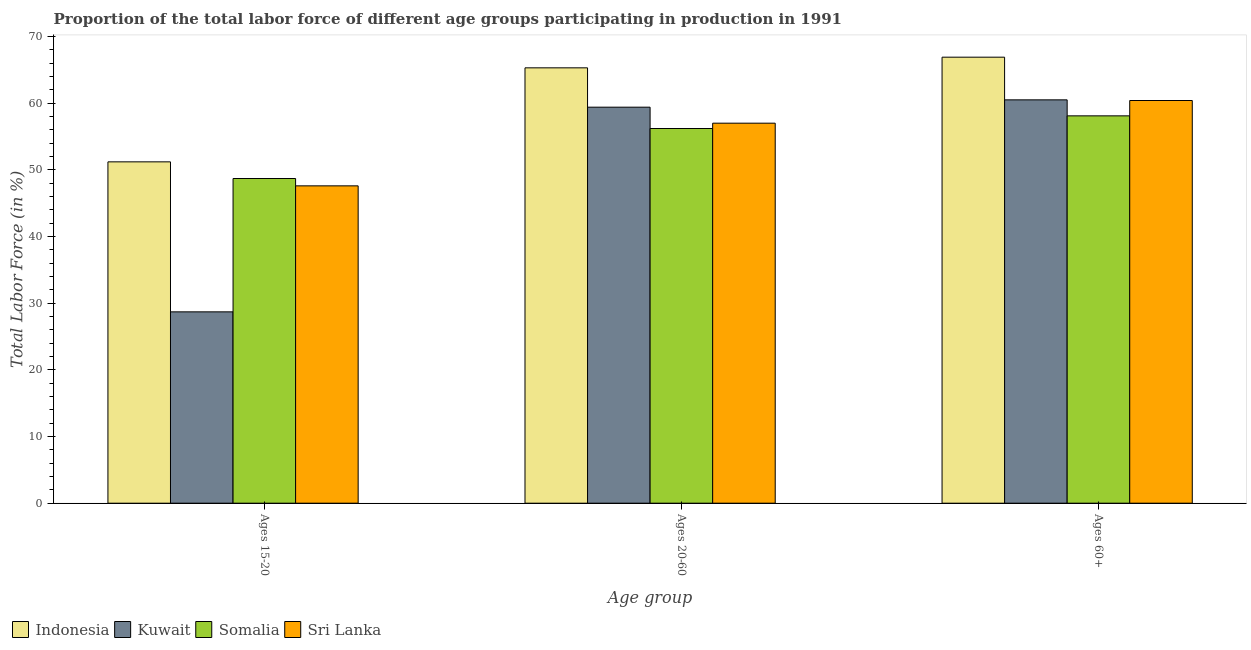How many different coloured bars are there?
Your answer should be very brief. 4. How many groups of bars are there?
Keep it short and to the point. 3. Are the number of bars per tick equal to the number of legend labels?
Offer a terse response. Yes. Are the number of bars on each tick of the X-axis equal?
Give a very brief answer. Yes. How many bars are there on the 2nd tick from the left?
Keep it short and to the point. 4. What is the label of the 2nd group of bars from the left?
Provide a short and direct response. Ages 20-60. What is the percentage of labor force within the age group 20-60 in Indonesia?
Provide a succinct answer. 65.3. Across all countries, what is the maximum percentage of labor force within the age group 15-20?
Provide a short and direct response. 51.2. Across all countries, what is the minimum percentage of labor force within the age group 20-60?
Your answer should be very brief. 56.2. In which country was the percentage of labor force above age 60 maximum?
Your answer should be very brief. Indonesia. In which country was the percentage of labor force within the age group 15-20 minimum?
Your response must be concise. Kuwait. What is the total percentage of labor force above age 60 in the graph?
Keep it short and to the point. 245.9. What is the difference between the percentage of labor force above age 60 in Somalia and that in Kuwait?
Provide a succinct answer. -2.4. What is the difference between the percentage of labor force above age 60 in Kuwait and the percentage of labor force within the age group 20-60 in Indonesia?
Provide a succinct answer. -4.8. What is the average percentage of labor force within the age group 15-20 per country?
Keep it short and to the point. 44.05. What is the difference between the percentage of labor force above age 60 and percentage of labor force within the age group 15-20 in Sri Lanka?
Your answer should be compact. 12.8. What is the ratio of the percentage of labor force within the age group 15-20 in Indonesia to that in Kuwait?
Provide a short and direct response. 1.78. Is the difference between the percentage of labor force above age 60 in Somalia and Kuwait greater than the difference between the percentage of labor force within the age group 20-60 in Somalia and Kuwait?
Provide a succinct answer. Yes. What is the difference between the highest and the second highest percentage of labor force above age 60?
Keep it short and to the point. 6.4. What is the difference between the highest and the lowest percentage of labor force within the age group 20-60?
Make the answer very short. 9.1. In how many countries, is the percentage of labor force above age 60 greater than the average percentage of labor force above age 60 taken over all countries?
Make the answer very short. 1. Is the sum of the percentage of labor force above age 60 in Indonesia and Somalia greater than the maximum percentage of labor force within the age group 15-20 across all countries?
Offer a very short reply. Yes. What does the 1st bar from the left in Ages 15-20 represents?
Provide a succinct answer. Indonesia. What does the 3rd bar from the right in Ages 60+ represents?
Your answer should be compact. Kuwait. How many bars are there?
Keep it short and to the point. 12. Are all the bars in the graph horizontal?
Provide a short and direct response. No. How many countries are there in the graph?
Provide a short and direct response. 4. What is the difference between two consecutive major ticks on the Y-axis?
Ensure brevity in your answer.  10. Does the graph contain any zero values?
Make the answer very short. No. Does the graph contain grids?
Your answer should be very brief. No. Where does the legend appear in the graph?
Provide a succinct answer. Bottom left. How many legend labels are there?
Give a very brief answer. 4. How are the legend labels stacked?
Provide a short and direct response. Horizontal. What is the title of the graph?
Provide a succinct answer. Proportion of the total labor force of different age groups participating in production in 1991. Does "Thailand" appear as one of the legend labels in the graph?
Provide a short and direct response. No. What is the label or title of the X-axis?
Your response must be concise. Age group. What is the label or title of the Y-axis?
Keep it short and to the point. Total Labor Force (in %). What is the Total Labor Force (in %) of Indonesia in Ages 15-20?
Your response must be concise. 51.2. What is the Total Labor Force (in %) in Kuwait in Ages 15-20?
Provide a short and direct response. 28.7. What is the Total Labor Force (in %) of Somalia in Ages 15-20?
Provide a succinct answer. 48.7. What is the Total Labor Force (in %) in Sri Lanka in Ages 15-20?
Offer a terse response. 47.6. What is the Total Labor Force (in %) in Indonesia in Ages 20-60?
Ensure brevity in your answer.  65.3. What is the Total Labor Force (in %) of Kuwait in Ages 20-60?
Provide a succinct answer. 59.4. What is the Total Labor Force (in %) of Somalia in Ages 20-60?
Offer a terse response. 56.2. What is the Total Labor Force (in %) of Indonesia in Ages 60+?
Offer a terse response. 66.9. What is the Total Labor Force (in %) of Kuwait in Ages 60+?
Provide a short and direct response. 60.5. What is the Total Labor Force (in %) in Somalia in Ages 60+?
Offer a very short reply. 58.1. What is the Total Labor Force (in %) of Sri Lanka in Ages 60+?
Give a very brief answer. 60.4. Across all Age group, what is the maximum Total Labor Force (in %) in Indonesia?
Ensure brevity in your answer.  66.9. Across all Age group, what is the maximum Total Labor Force (in %) of Kuwait?
Offer a terse response. 60.5. Across all Age group, what is the maximum Total Labor Force (in %) of Somalia?
Offer a terse response. 58.1. Across all Age group, what is the maximum Total Labor Force (in %) in Sri Lanka?
Ensure brevity in your answer.  60.4. Across all Age group, what is the minimum Total Labor Force (in %) of Indonesia?
Give a very brief answer. 51.2. Across all Age group, what is the minimum Total Labor Force (in %) of Kuwait?
Provide a succinct answer. 28.7. Across all Age group, what is the minimum Total Labor Force (in %) of Somalia?
Offer a terse response. 48.7. Across all Age group, what is the minimum Total Labor Force (in %) in Sri Lanka?
Provide a succinct answer. 47.6. What is the total Total Labor Force (in %) of Indonesia in the graph?
Ensure brevity in your answer.  183.4. What is the total Total Labor Force (in %) in Kuwait in the graph?
Keep it short and to the point. 148.6. What is the total Total Labor Force (in %) of Somalia in the graph?
Keep it short and to the point. 163. What is the total Total Labor Force (in %) in Sri Lanka in the graph?
Offer a terse response. 165. What is the difference between the Total Labor Force (in %) in Indonesia in Ages 15-20 and that in Ages 20-60?
Offer a very short reply. -14.1. What is the difference between the Total Labor Force (in %) of Kuwait in Ages 15-20 and that in Ages 20-60?
Your answer should be very brief. -30.7. What is the difference between the Total Labor Force (in %) in Sri Lanka in Ages 15-20 and that in Ages 20-60?
Provide a succinct answer. -9.4. What is the difference between the Total Labor Force (in %) in Indonesia in Ages 15-20 and that in Ages 60+?
Give a very brief answer. -15.7. What is the difference between the Total Labor Force (in %) of Kuwait in Ages 15-20 and that in Ages 60+?
Ensure brevity in your answer.  -31.8. What is the difference between the Total Labor Force (in %) of Sri Lanka in Ages 15-20 and that in Ages 60+?
Offer a very short reply. -12.8. What is the difference between the Total Labor Force (in %) of Indonesia in Ages 20-60 and that in Ages 60+?
Provide a short and direct response. -1.6. What is the difference between the Total Labor Force (in %) in Kuwait in Ages 20-60 and that in Ages 60+?
Ensure brevity in your answer.  -1.1. What is the difference between the Total Labor Force (in %) of Somalia in Ages 20-60 and that in Ages 60+?
Provide a succinct answer. -1.9. What is the difference between the Total Labor Force (in %) of Sri Lanka in Ages 20-60 and that in Ages 60+?
Provide a short and direct response. -3.4. What is the difference between the Total Labor Force (in %) of Indonesia in Ages 15-20 and the Total Labor Force (in %) of Sri Lanka in Ages 20-60?
Your response must be concise. -5.8. What is the difference between the Total Labor Force (in %) of Kuwait in Ages 15-20 and the Total Labor Force (in %) of Somalia in Ages 20-60?
Make the answer very short. -27.5. What is the difference between the Total Labor Force (in %) in Kuwait in Ages 15-20 and the Total Labor Force (in %) in Sri Lanka in Ages 20-60?
Ensure brevity in your answer.  -28.3. What is the difference between the Total Labor Force (in %) in Indonesia in Ages 15-20 and the Total Labor Force (in %) in Kuwait in Ages 60+?
Your response must be concise. -9.3. What is the difference between the Total Labor Force (in %) in Indonesia in Ages 15-20 and the Total Labor Force (in %) in Somalia in Ages 60+?
Give a very brief answer. -6.9. What is the difference between the Total Labor Force (in %) of Kuwait in Ages 15-20 and the Total Labor Force (in %) of Somalia in Ages 60+?
Your response must be concise. -29.4. What is the difference between the Total Labor Force (in %) in Kuwait in Ages 15-20 and the Total Labor Force (in %) in Sri Lanka in Ages 60+?
Make the answer very short. -31.7. What is the difference between the Total Labor Force (in %) of Somalia in Ages 15-20 and the Total Labor Force (in %) of Sri Lanka in Ages 60+?
Give a very brief answer. -11.7. What is the difference between the Total Labor Force (in %) of Indonesia in Ages 20-60 and the Total Labor Force (in %) of Kuwait in Ages 60+?
Give a very brief answer. 4.8. What is the difference between the Total Labor Force (in %) in Indonesia in Ages 20-60 and the Total Labor Force (in %) in Sri Lanka in Ages 60+?
Your answer should be compact. 4.9. What is the average Total Labor Force (in %) in Indonesia per Age group?
Ensure brevity in your answer.  61.13. What is the average Total Labor Force (in %) of Kuwait per Age group?
Give a very brief answer. 49.53. What is the average Total Labor Force (in %) in Somalia per Age group?
Your answer should be compact. 54.33. What is the difference between the Total Labor Force (in %) of Indonesia and Total Labor Force (in %) of Somalia in Ages 15-20?
Offer a very short reply. 2.5. What is the difference between the Total Labor Force (in %) in Indonesia and Total Labor Force (in %) in Sri Lanka in Ages 15-20?
Offer a terse response. 3.6. What is the difference between the Total Labor Force (in %) of Kuwait and Total Labor Force (in %) of Somalia in Ages 15-20?
Give a very brief answer. -20. What is the difference between the Total Labor Force (in %) in Kuwait and Total Labor Force (in %) in Sri Lanka in Ages 15-20?
Your answer should be compact. -18.9. What is the difference between the Total Labor Force (in %) in Indonesia and Total Labor Force (in %) in Somalia in Ages 20-60?
Keep it short and to the point. 9.1. What is the difference between the Total Labor Force (in %) of Indonesia and Total Labor Force (in %) of Sri Lanka in Ages 20-60?
Your response must be concise. 8.3. What is the difference between the Total Labor Force (in %) of Kuwait and Total Labor Force (in %) of Somalia in Ages 20-60?
Provide a short and direct response. 3.2. What is the difference between the Total Labor Force (in %) of Kuwait and Total Labor Force (in %) of Sri Lanka in Ages 20-60?
Make the answer very short. 2.4. What is the difference between the Total Labor Force (in %) of Indonesia and Total Labor Force (in %) of Somalia in Ages 60+?
Provide a succinct answer. 8.8. What is the difference between the Total Labor Force (in %) in Kuwait and Total Labor Force (in %) in Somalia in Ages 60+?
Ensure brevity in your answer.  2.4. What is the difference between the Total Labor Force (in %) of Somalia and Total Labor Force (in %) of Sri Lanka in Ages 60+?
Your answer should be very brief. -2.3. What is the ratio of the Total Labor Force (in %) of Indonesia in Ages 15-20 to that in Ages 20-60?
Ensure brevity in your answer.  0.78. What is the ratio of the Total Labor Force (in %) of Kuwait in Ages 15-20 to that in Ages 20-60?
Keep it short and to the point. 0.48. What is the ratio of the Total Labor Force (in %) in Somalia in Ages 15-20 to that in Ages 20-60?
Offer a terse response. 0.87. What is the ratio of the Total Labor Force (in %) of Sri Lanka in Ages 15-20 to that in Ages 20-60?
Your answer should be very brief. 0.84. What is the ratio of the Total Labor Force (in %) in Indonesia in Ages 15-20 to that in Ages 60+?
Your answer should be very brief. 0.77. What is the ratio of the Total Labor Force (in %) of Kuwait in Ages 15-20 to that in Ages 60+?
Your answer should be very brief. 0.47. What is the ratio of the Total Labor Force (in %) of Somalia in Ages 15-20 to that in Ages 60+?
Provide a short and direct response. 0.84. What is the ratio of the Total Labor Force (in %) of Sri Lanka in Ages 15-20 to that in Ages 60+?
Offer a very short reply. 0.79. What is the ratio of the Total Labor Force (in %) in Indonesia in Ages 20-60 to that in Ages 60+?
Provide a short and direct response. 0.98. What is the ratio of the Total Labor Force (in %) of Kuwait in Ages 20-60 to that in Ages 60+?
Provide a succinct answer. 0.98. What is the ratio of the Total Labor Force (in %) of Somalia in Ages 20-60 to that in Ages 60+?
Provide a short and direct response. 0.97. What is the ratio of the Total Labor Force (in %) in Sri Lanka in Ages 20-60 to that in Ages 60+?
Keep it short and to the point. 0.94. What is the difference between the highest and the lowest Total Labor Force (in %) of Kuwait?
Give a very brief answer. 31.8. What is the difference between the highest and the lowest Total Labor Force (in %) of Sri Lanka?
Offer a very short reply. 12.8. 